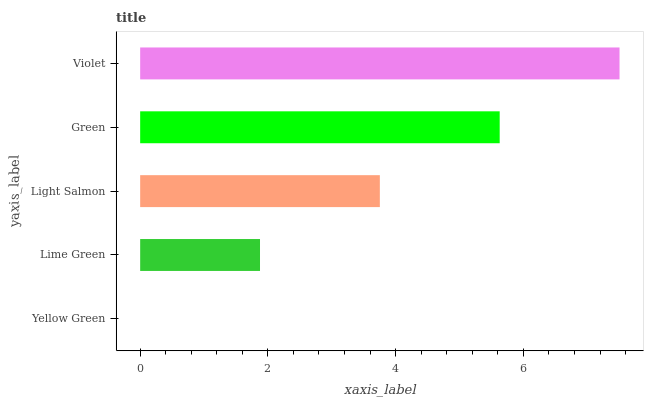Is Yellow Green the minimum?
Answer yes or no. Yes. Is Violet the maximum?
Answer yes or no. Yes. Is Lime Green the minimum?
Answer yes or no. No. Is Lime Green the maximum?
Answer yes or no. No. Is Lime Green greater than Yellow Green?
Answer yes or no. Yes. Is Yellow Green less than Lime Green?
Answer yes or no. Yes. Is Yellow Green greater than Lime Green?
Answer yes or no. No. Is Lime Green less than Yellow Green?
Answer yes or no. No. Is Light Salmon the high median?
Answer yes or no. Yes. Is Light Salmon the low median?
Answer yes or no. Yes. Is Green the high median?
Answer yes or no. No. Is Lime Green the low median?
Answer yes or no. No. 